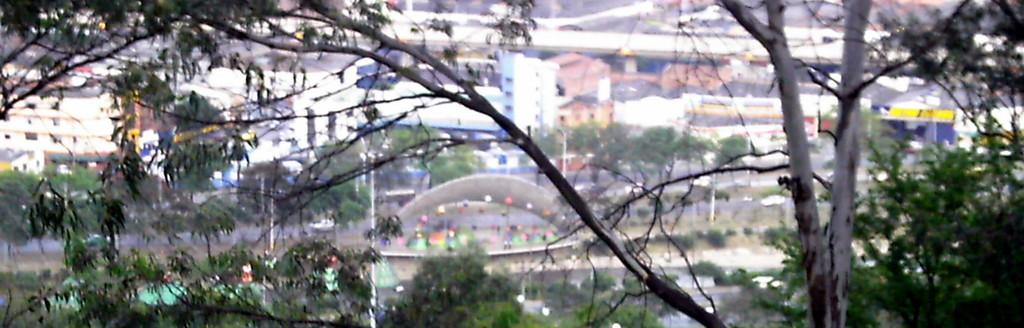What can be seen in the foreground of the picture? There are trees in the foreground of the picture. How would you describe the background of the image? The background of the image is blurred. What type of structures are visible in the background? There are buildings in the background of the image. What else can be seen in the background besides buildings? There are trees and poles in the background of the image, as well as other objects. What is the weight of the sand in the image? There is no sand present in the image, so it is not possible to determine its weight. 